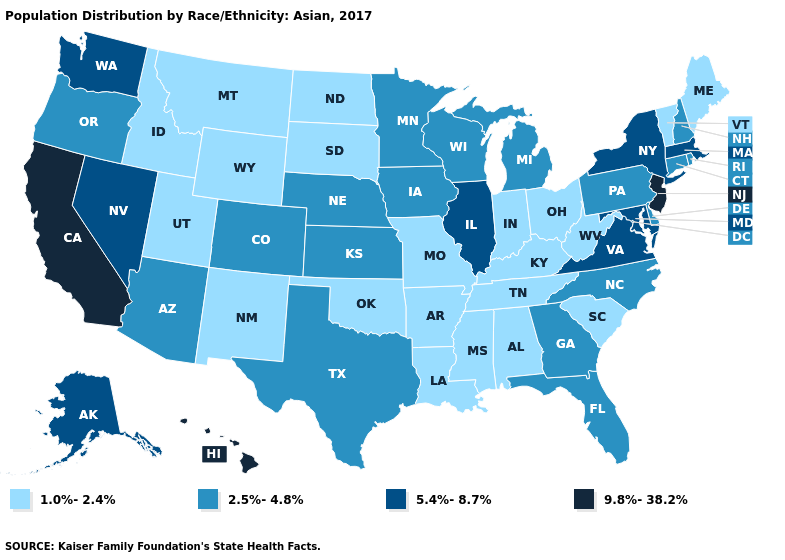Does the first symbol in the legend represent the smallest category?
Keep it brief. Yes. What is the highest value in the MidWest ?
Quick response, please. 5.4%-8.7%. Is the legend a continuous bar?
Concise answer only. No. Name the states that have a value in the range 5.4%-8.7%?
Write a very short answer. Alaska, Illinois, Maryland, Massachusetts, Nevada, New York, Virginia, Washington. Is the legend a continuous bar?
Give a very brief answer. No. Which states have the lowest value in the South?
Be succinct. Alabama, Arkansas, Kentucky, Louisiana, Mississippi, Oklahoma, South Carolina, Tennessee, West Virginia. Among the states that border Washington , which have the highest value?
Write a very short answer. Oregon. What is the value of New Jersey?
Quick response, please. 9.8%-38.2%. Which states have the lowest value in the MidWest?
Short answer required. Indiana, Missouri, North Dakota, Ohio, South Dakota. Name the states that have a value in the range 2.5%-4.8%?
Quick response, please. Arizona, Colorado, Connecticut, Delaware, Florida, Georgia, Iowa, Kansas, Michigan, Minnesota, Nebraska, New Hampshire, North Carolina, Oregon, Pennsylvania, Rhode Island, Texas, Wisconsin. What is the value of Texas?
Answer briefly. 2.5%-4.8%. Does Iowa have the highest value in the USA?
Short answer required. No. Does Indiana have the same value as Massachusetts?
Be succinct. No. Does the first symbol in the legend represent the smallest category?
Keep it brief. Yes. Name the states that have a value in the range 9.8%-38.2%?
Keep it brief. California, Hawaii, New Jersey. 